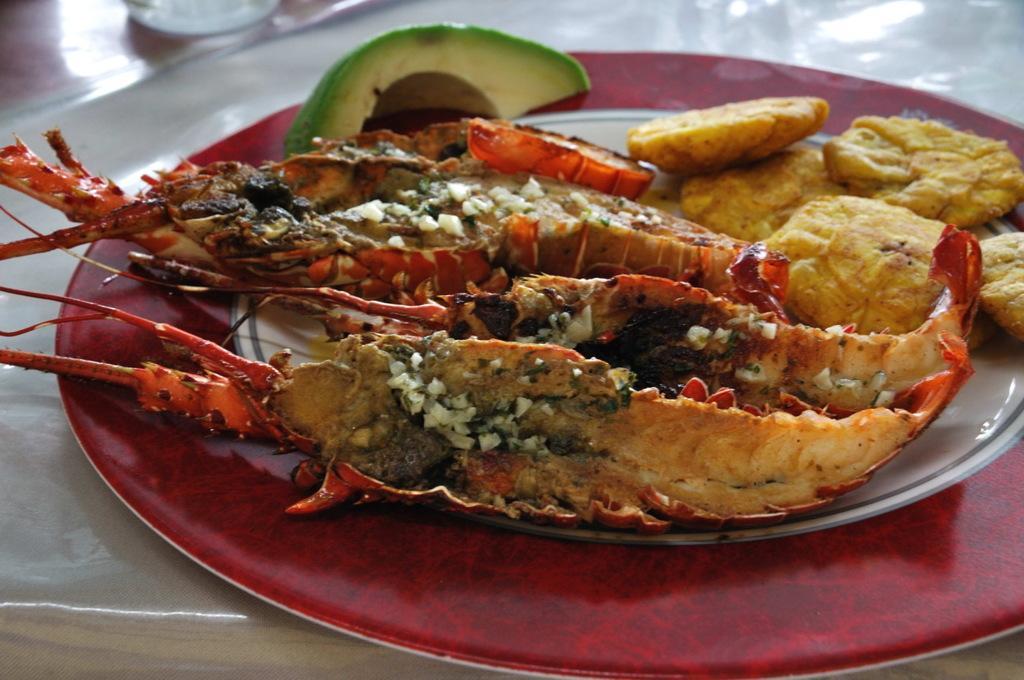Describe this image in one or two sentences. In this picture, we see a red and white plate containing the food item is placed on the white table. 